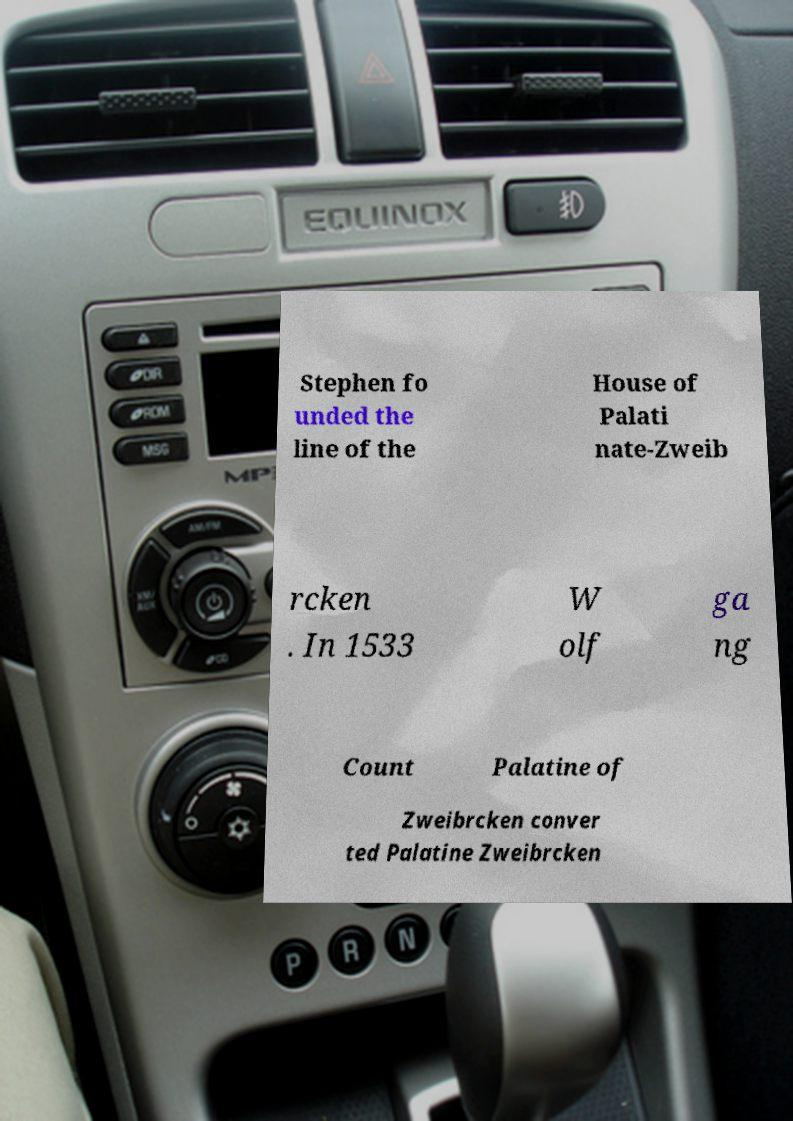Could you extract and type out the text from this image? Stephen fo unded the line of the House of Palati nate-Zweib rcken . In 1533 W olf ga ng Count Palatine of Zweibrcken conver ted Palatine Zweibrcken 